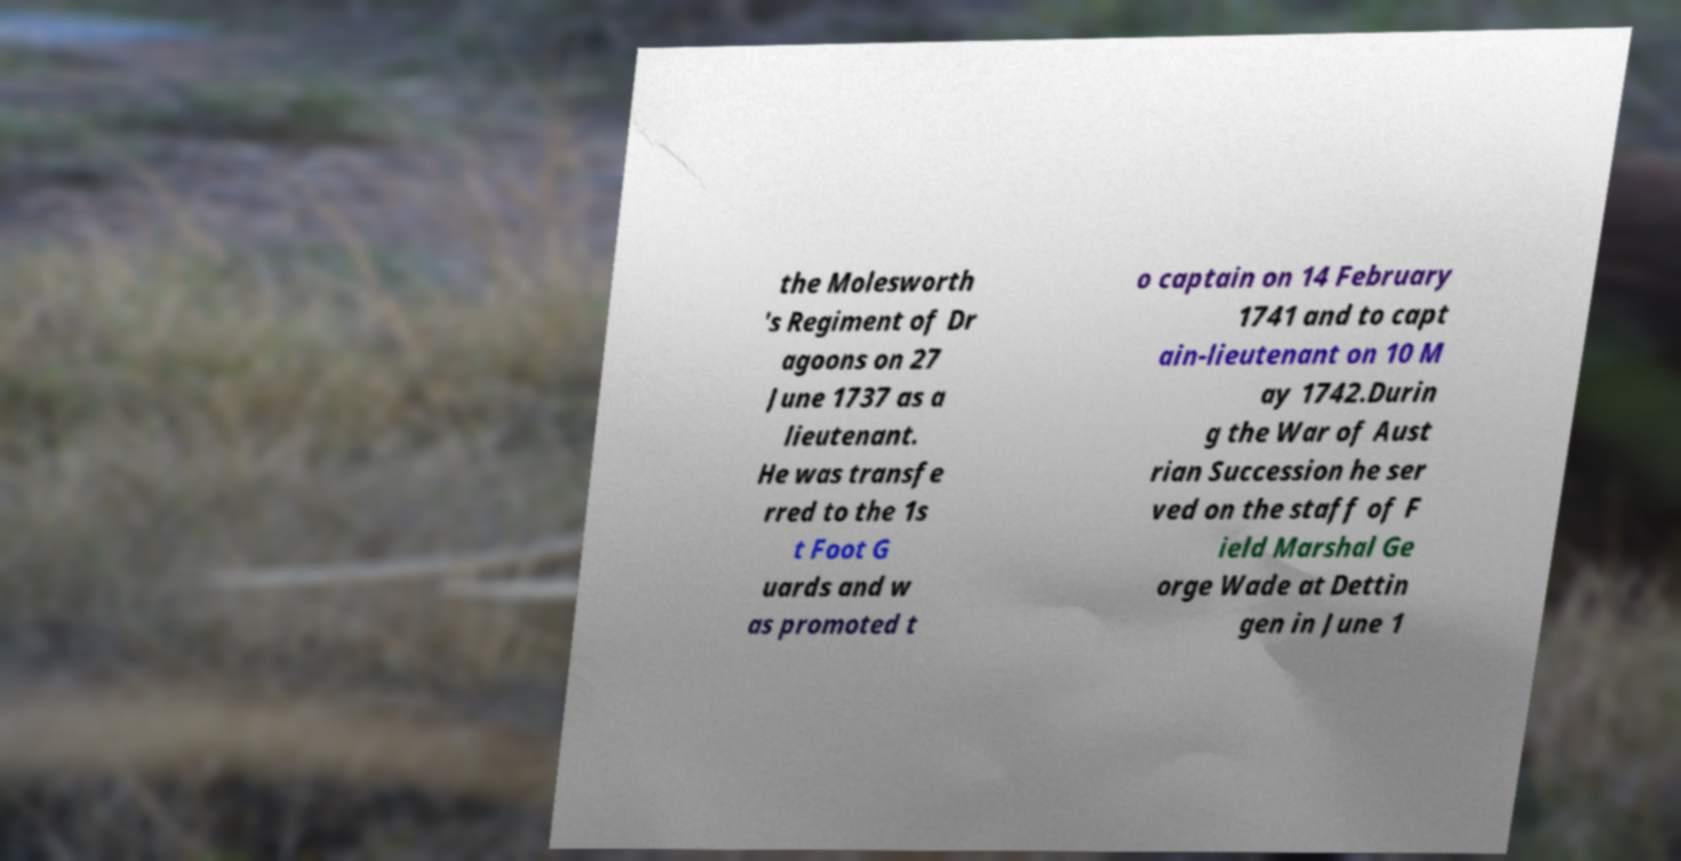Please identify and transcribe the text found in this image. the Molesworth 's Regiment of Dr agoons on 27 June 1737 as a lieutenant. He was transfe rred to the 1s t Foot G uards and w as promoted t o captain on 14 February 1741 and to capt ain-lieutenant on 10 M ay 1742.Durin g the War of Aust rian Succession he ser ved on the staff of F ield Marshal Ge orge Wade at Dettin gen in June 1 